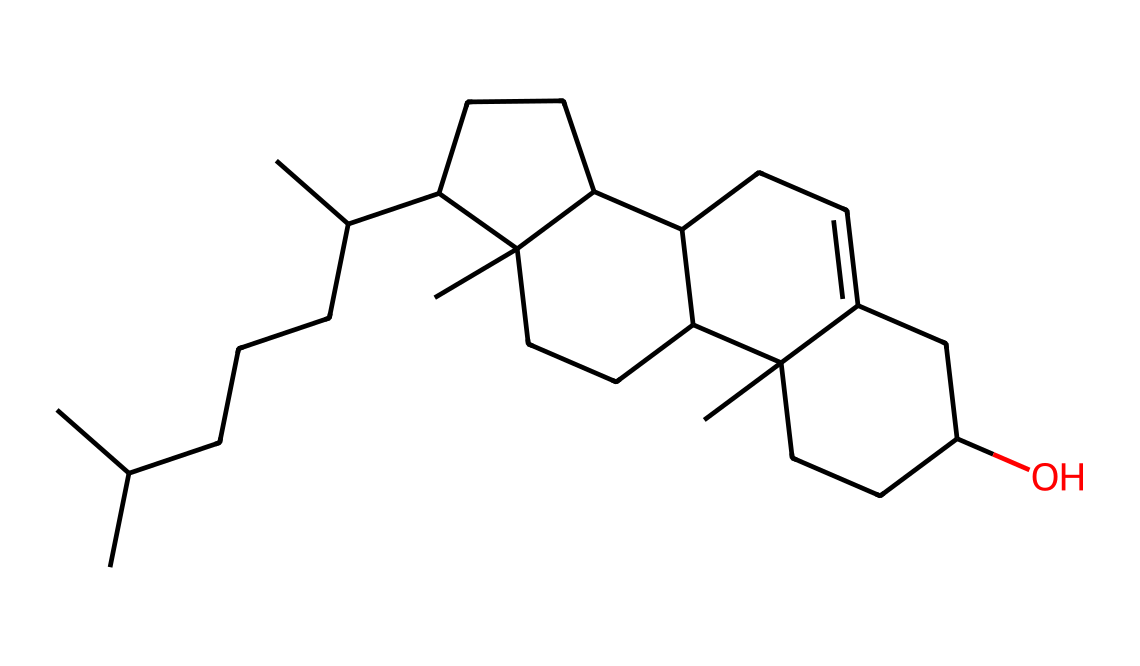What is the primary type of lipid represented by this structure? This chemical structure represents a sterol, which is a specific category of lipids characterized by a core structure of four fused hydrocarbon rings and an alcohol group. Cholesterol is a well-known sterol.
Answer: sterol How many carbon atoms are in this cholesterol molecule? To count the carbon atoms, examine the SMILES representation and identify each "C" symbol. The total number of carbon atoms in this representation is 27.
Answer: 27 Does this chemical structure include a hydroxyl (-OH) group? The presence of a hydroxyl group is indicated by "O" in the SMILES. This structure contains a hydroxyl group, which is characteristic of alcohols and affects the chemical's solubility and polarity.
Answer: yes What physical state might preserved cholesterol typically be found in? Considering that cholesterol is a lipid and its saturated nature, it is likely to be solid at room temperature, especially in the context of preserved animal fats where other saturated lipids may also be present.
Answer: solid How does the structure of cholesterol contribute to its function in biological membranes? Cholesterol has a bulky hydrophobic structure with both hydrophobic rings and a hydrophilic hydroxyl group. This amphipathic property allows it to fit between phospholipids in cell membranes, providing fluidity and stability under varying temperature conditions.
Answer: amphipathic Which part of the cholesterol structure indicates a double bond? In the SMILES representation, a double bond is indicated by the presence of "C=C" which shows unsaturation. The presence of these bonds plays a critical role in determining the shape and functionality of the molecule.
Answer: C=C 